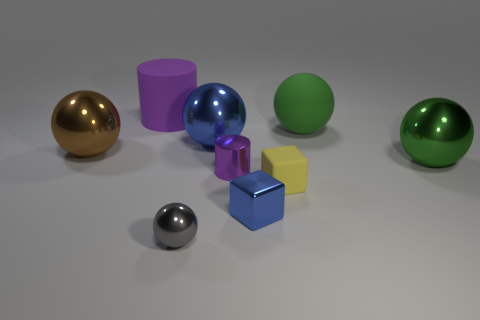Subtract all blue shiny balls. How many balls are left? 4 Subtract all purple cylinders. How many green balls are left? 2 Subtract all gray balls. How many balls are left? 4 Subtract 3 spheres. How many spheres are left? 2 Subtract all brown spheres. Subtract all red cylinders. How many spheres are left? 4 Subtract all cubes. How many objects are left? 7 Add 4 yellow rubber things. How many yellow rubber things are left? 5 Add 9 big brown balls. How many big brown balls exist? 10 Subtract 2 green balls. How many objects are left? 7 Subtract all yellow rubber balls. Subtract all yellow objects. How many objects are left? 8 